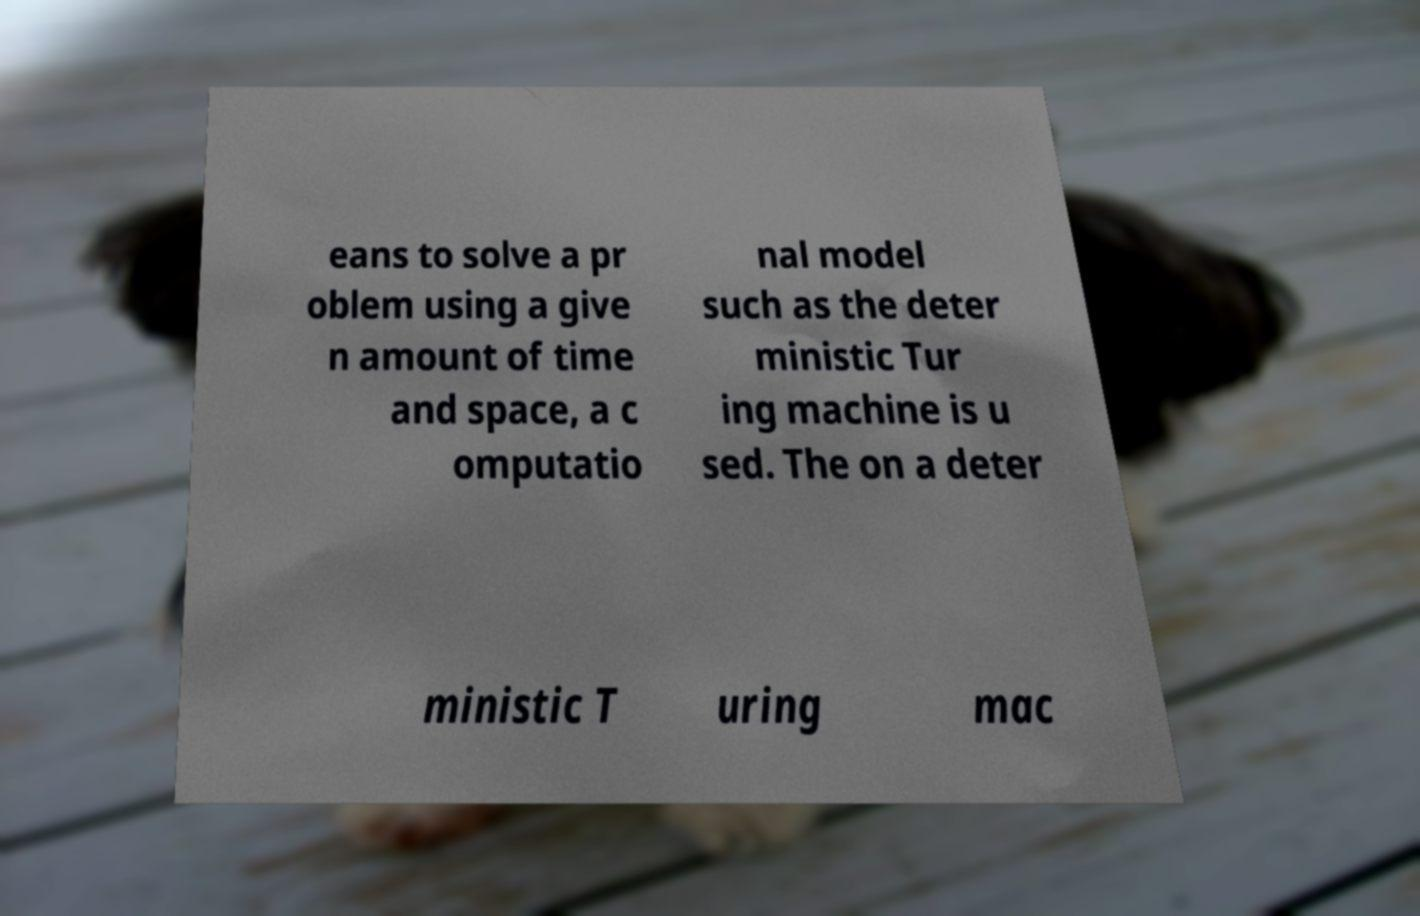There's text embedded in this image that I need extracted. Can you transcribe it verbatim? eans to solve a pr oblem using a give n amount of time and space, a c omputatio nal model such as the deter ministic Tur ing machine is u sed. The on a deter ministic T uring mac 